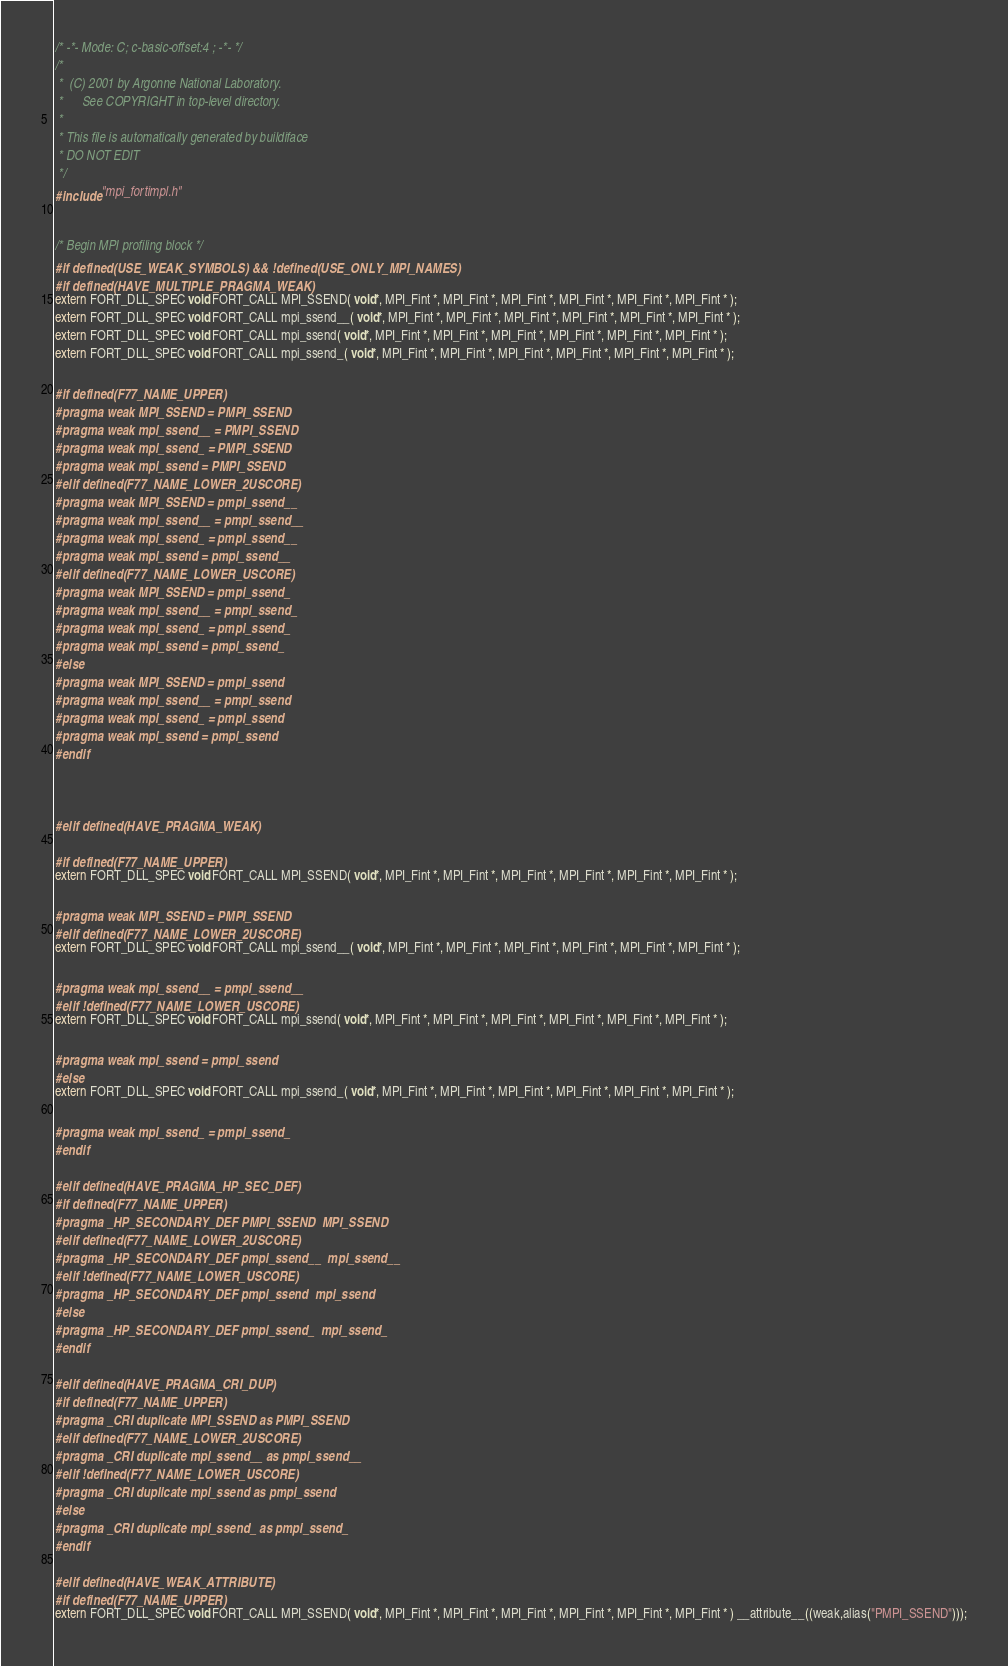Convert code to text. <code><loc_0><loc_0><loc_500><loc_500><_C_>/* -*- Mode: C; c-basic-offset:4 ; -*- */
/*  
 *  (C) 2001 by Argonne National Laboratory.
 *      See COPYRIGHT in top-level directory.
 *
 * This file is automatically generated by buildiface 
 * DO NOT EDIT
 */
#include "mpi_fortimpl.h"


/* Begin MPI profiling block */
#if defined(USE_WEAK_SYMBOLS) && !defined(USE_ONLY_MPI_NAMES) 
#if defined(HAVE_MULTIPLE_PRAGMA_WEAK)
extern FORT_DLL_SPEC void FORT_CALL MPI_SSEND( void*, MPI_Fint *, MPI_Fint *, MPI_Fint *, MPI_Fint *, MPI_Fint *, MPI_Fint * );
extern FORT_DLL_SPEC void FORT_CALL mpi_ssend__( void*, MPI_Fint *, MPI_Fint *, MPI_Fint *, MPI_Fint *, MPI_Fint *, MPI_Fint * );
extern FORT_DLL_SPEC void FORT_CALL mpi_ssend( void*, MPI_Fint *, MPI_Fint *, MPI_Fint *, MPI_Fint *, MPI_Fint *, MPI_Fint * );
extern FORT_DLL_SPEC void FORT_CALL mpi_ssend_( void*, MPI_Fint *, MPI_Fint *, MPI_Fint *, MPI_Fint *, MPI_Fint *, MPI_Fint * );

#if defined(F77_NAME_UPPER)
#pragma weak MPI_SSEND = PMPI_SSEND
#pragma weak mpi_ssend__ = PMPI_SSEND
#pragma weak mpi_ssend_ = PMPI_SSEND
#pragma weak mpi_ssend = PMPI_SSEND
#elif defined(F77_NAME_LOWER_2USCORE)
#pragma weak MPI_SSEND = pmpi_ssend__
#pragma weak mpi_ssend__ = pmpi_ssend__
#pragma weak mpi_ssend_ = pmpi_ssend__
#pragma weak mpi_ssend = pmpi_ssend__
#elif defined(F77_NAME_LOWER_USCORE)
#pragma weak MPI_SSEND = pmpi_ssend_
#pragma weak mpi_ssend__ = pmpi_ssend_
#pragma weak mpi_ssend_ = pmpi_ssend_
#pragma weak mpi_ssend = pmpi_ssend_
#else
#pragma weak MPI_SSEND = pmpi_ssend
#pragma weak mpi_ssend__ = pmpi_ssend
#pragma weak mpi_ssend_ = pmpi_ssend
#pragma weak mpi_ssend = pmpi_ssend
#endif



#elif defined(HAVE_PRAGMA_WEAK)

#if defined(F77_NAME_UPPER)
extern FORT_DLL_SPEC void FORT_CALL MPI_SSEND( void*, MPI_Fint *, MPI_Fint *, MPI_Fint *, MPI_Fint *, MPI_Fint *, MPI_Fint * );

#pragma weak MPI_SSEND = PMPI_SSEND
#elif defined(F77_NAME_LOWER_2USCORE)
extern FORT_DLL_SPEC void FORT_CALL mpi_ssend__( void*, MPI_Fint *, MPI_Fint *, MPI_Fint *, MPI_Fint *, MPI_Fint *, MPI_Fint * );

#pragma weak mpi_ssend__ = pmpi_ssend__
#elif !defined(F77_NAME_LOWER_USCORE)
extern FORT_DLL_SPEC void FORT_CALL mpi_ssend( void*, MPI_Fint *, MPI_Fint *, MPI_Fint *, MPI_Fint *, MPI_Fint *, MPI_Fint * );

#pragma weak mpi_ssend = pmpi_ssend
#else
extern FORT_DLL_SPEC void FORT_CALL mpi_ssend_( void*, MPI_Fint *, MPI_Fint *, MPI_Fint *, MPI_Fint *, MPI_Fint *, MPI_Fint * );

#pragma weak mpi_ssend_ = pmpi_ssend_
#endif

#elif defined(HAVE_PRAGMA_HP_SEC_DEF)
#if defined(F77_NAME_UPPER)
#pragma _HP_SECONDARY_DEF PMPI_SSEND  MPI_SSEND
#elif defined(F77_NAME_LOWER_2USCORE)
#pragma _HP_SECONDARY_DEF pmpi_ssend__  mpi_ssend__
#elif !defined(F77_NAME_LOWER_USCORE)
#pragma _HP_SECONDARY_DEF pmpi_ssend  mpi_ssend
#else
#pragma _HP_SECONDARY_DEF pmpi_ssend_  mpi_ssend_
#endif

#elif defined(HAVE_PRAGMA_CRI_DUP)
#if defined(F77_NAME_UPPER)
#pragma _CRI duplicate MPI_SSEND as PMPI_SSEND
#elif defined(F77_NAME_LOWER_2USCORE)
#pragma _CRI duplicate mpi_ssend__ as pmpi_ssend__
#elif !defined(F77_NAME_LOWER_USCORE)
#pragma _CRI duplicate mpi_ssend as pmpi_ssend
#else
#pragma _CRI duplicate mpi_ssend_ as pmpi_ssend_
#endif

#elif defined(HAVE_WEAK_ATTRIBUTE)
#if defined(F77_NAME_UPPER)
extern FORT_DLL_SPEC void FORT_CALL MPI_SSEND( void*, MPI_Fint *, MPI_Fint *, MPI_Fint *, MPI_Fint *, MPI_Fint *, MPI_Fint * ) __attribute__((weak,alias("PMPI_SSEND")));</code> 